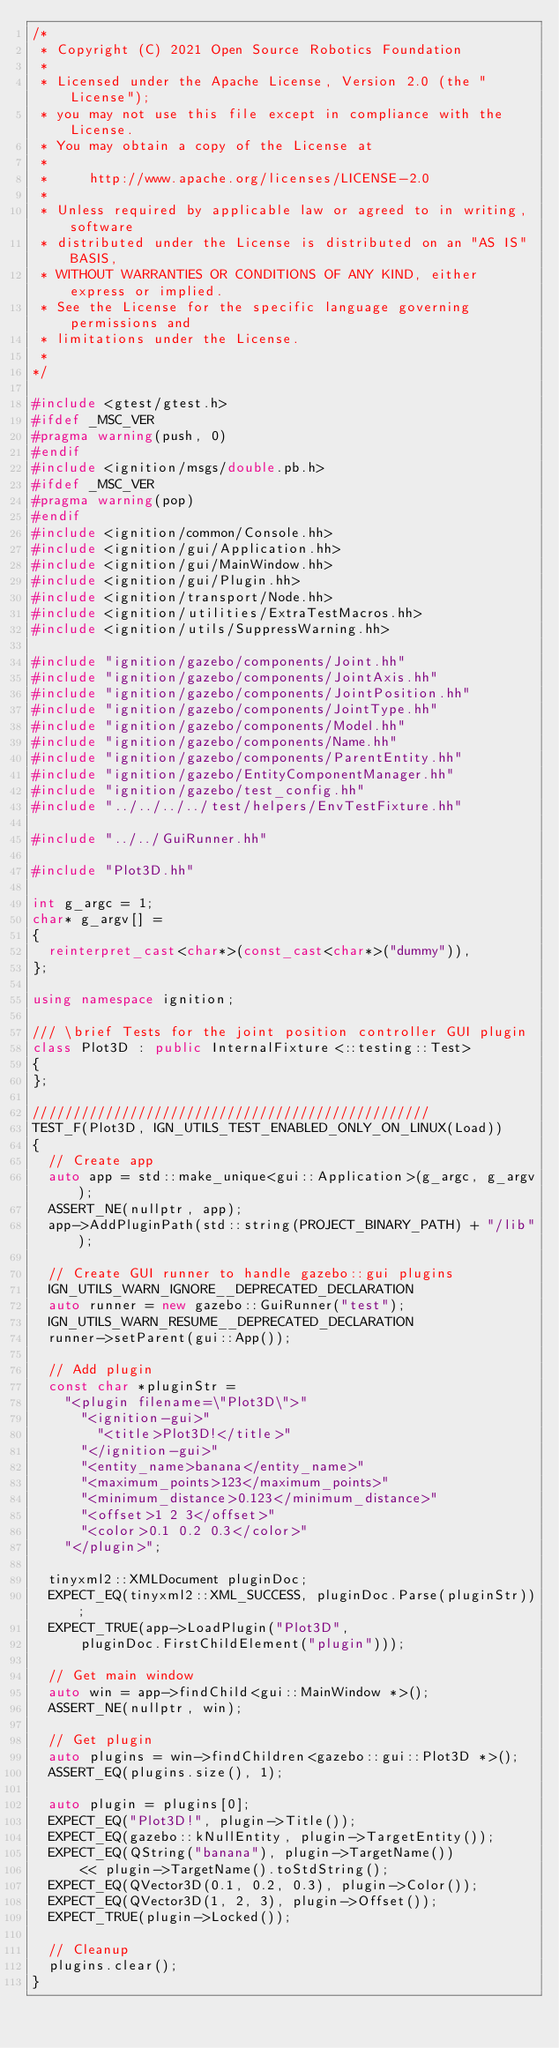<code> <loc_0><loc_0><loc_500><loc_500><_C++_>/*
 * Copyright (C) 2021 Open Source Robotics Foundation
 *
 * Licensed under the Apache License, Version 2.0 (the "License");
 * you may not use this file except in compliance with the License.
 * You may obtain a copy of the License at
 *
 *     http://www.apache.org/licenses/LICENSE-2.0
 *
 * Unless required by applicable law or agreed to in writing, software
 * distributed under the License is distributed on an "AS IS" BASIS,
 * WITHOUT WARRANTIES OR CONDITIONS OF ANY KIND, either express or implied.
 * See the License for the specific language governing permissions and
 * limitations under the License.
 *
*/

#include <gtest/gtest.h>
#ifdef _MSC_VER
#pragma warning(push, 0)
#endif
#include <ignition/msgs/double.pb.h>
#ifdef _MSC_VER
#pragma warning(pop)
#endif
#include <ignition/common/Console.hh>
#include <ignition/gui/Application.hh>
#include <ignition/gui/MainWindow.hh>
#include <ignition/gui/Plugin.hh>
#include <ignition/transport/Node.hh>
#include <ignition/utilities/ExtraTestMacros.hh>
#include <ignition/utils/SuppressWarning.hh>

#include "ignition/gazebo/components/Joint.hh"
#include "ignition/gazebo/components/JointAxis.hh"
#include "ignition/gazebo/components/JointPosition.hh"
#include "ignition/gazebo/components/JointType.hh"
#include "ignition/gazebo/components/Model.hh"
#include "ignition/gazebo/components/Name.hh"
#include "ignition/gazebo/components/ParentEntity.hh"
#include "ignition/gazebo/EntityComponentManager.hh"
#include "ignition/gazebo/test_config.hh"
#include "../../../../test/helpers/EnvTestFixture.hh"

#include "../../GuiRunner.hh"

#include "Plot3D.hh"

int g_argc = 1;
char* g_argv[] =
{
  reinterpret_cast<char*>(const_cast<char*>("dummy")),
};

using namespace ignition;

/// \brief Tests for the joint position controller GUI plugin
class Plot3D : public InternalFixture<::testing::Test>
{
};

/////////////////////////////////////////////////
TEST_F(Plot3D, IGN_UTILS_TEST_ENABLED_ONLY_ON_LINUX(Load))
{
  // Create app
  auto app = std::make_unique<gui::Application>(g_argc, g_argv);
  ASSERT_NE(nullptr, app);
  app->AddPluginPath(std::string(PROJECT_BINARY_PATH) + "/lib");

  // Create GUI runner to handle gazebo::gui plugins
  IGN_UTILS_WARN_IGNORE__DEPRECATED_DECLARATION
  auto runner = new gazebo::GuiRunner("test");
  IGN_UTILS_WARN_RESUME__DEPRECATED_DECLARATION
  runner->setParent(gui::App());

  // Add plugin
  const char *pluginStr =
    "<plugin filename=\"Plot3D\">"
      "<ignition-gui>"
        "<title>Plot3D!</title>"
      "</ignition-gui>"
      "<entity_name>banana</entity_name>"
      "<maximum_points>123</maximum_points>"
      "<minimum_distance>0.123</minimum_distance>"
      "<offset>1 2 3</offset>"
      "<color>0.1 0.2 0.3</color>"
    "</plugin>";

  tinyxml2::XMLDocument pluginDoc;
  EXPECT_EQ(tinyxml2::XML_SUCCESS, pluginDoc.Parse(pluginStr));
  EXPECT_TRUE(app->LoadPlugin("Plot3D",
      pluginDoc.FirstChildElement("plugin")));

  // Get main window
  auto win = app->findChild<gui::MainWindow *>();
  ASSERT_NE(nullptr, win);

  // Get plugin
  auto plugins = win->findChildren<gazebo::gui::Plot3D *>();
  ASSERT_EQ(plugins.size(), 1);

  auto plugin = plugins[0];
  EXPECT_EQ("Plot3D!", plugin->Title());
  EXPECT_EQ(gazebo::kNullEntity, plugin->TargetEntity());
  EXPECT_EQ(QString("banana"), plugin->TargetName())
      << plugin->TargetName().toStdString();
  EXPECT_EQ(QVector3D(0.1, 0.2, 0.3), plugin->Color());
  EXPECT_EQ(QVector3D(1, 2, 3), plugin->Offset());
  EXPECT_TRUE(plugin->Locked());

  // Cleanup
  plugins.clear();
}
</code> 